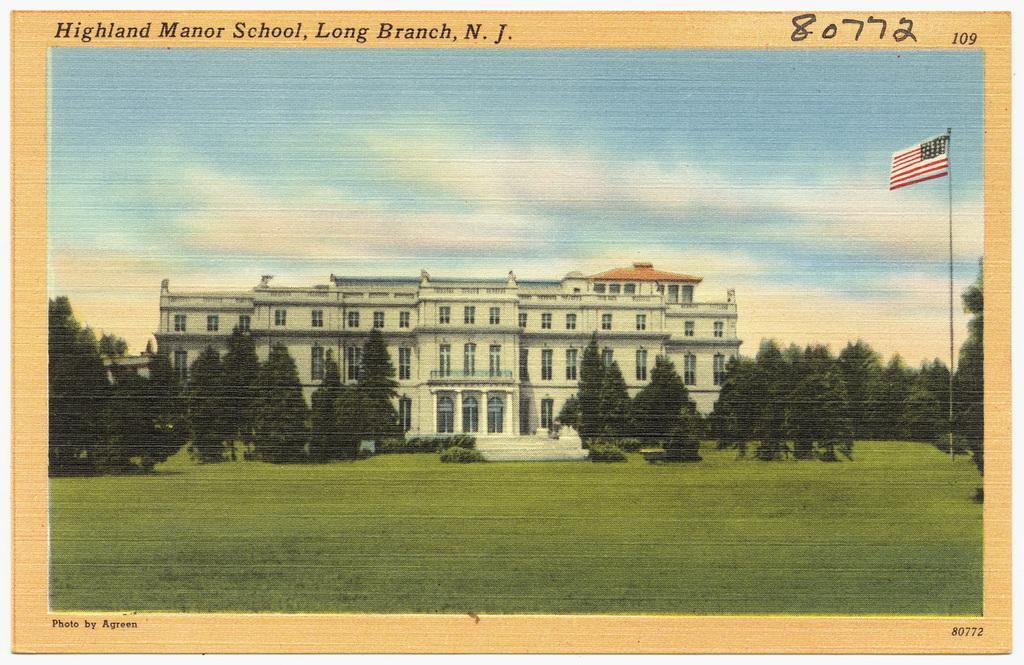How would you summarize this image in a sentence or two? This is an edited picture. In this image there is a building and there are trees and there is a flag. At the top there is sky and there are clouds. At the top of the image there is a text. At the bottom of the image there is a text. 